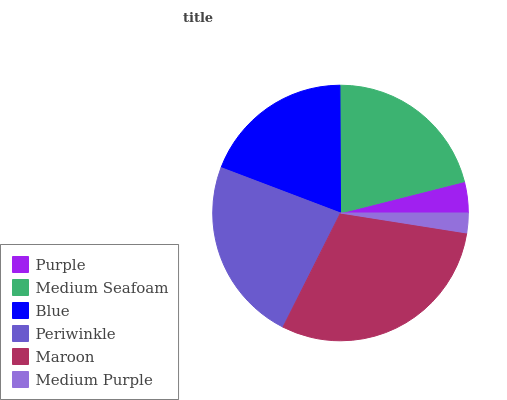Is Medium Purple the minimum?
Answer yes or no. Yes. Is Maroon the maximum?
Answer yes or no. Yes. Is Medium Seafoam the minimum?
Answer yes or no. No. Is Medium Seafoam the maximum?
Answer yes or no. No. Is Medium Seafoam greater than Purple?
Answer yes or no. Yes. Is Purple less than Medium Seafoam?
Answer yes or no. Yes. Is Purple greater than Medium Seafoam?
Answer yes or no. No. Is Medium Seafoam less than Purple?
Answer yes or no. No. Is Medium Seafoam the high median?
Answer yes or no. Yes. Is Blue the low median?
Answer yes or no. Yes. Is Purple the high median?
Answer yes or no. No. Is Maroon the low median?
Answer yes or no. No. 